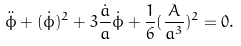Convert formula to latex. <formula><loc_0><loc_0><loc_500><loc_500>\ddot { \phi } + ( \dot { \phi } ) ^ { 2 } + 3 \frac { \dot { a } } { a } \dot { \phi } + \frac { 1 } { 6 } ( \frac { A } { a ^ { 3 } } ) ^ { 2 } = 0 .</formula> 